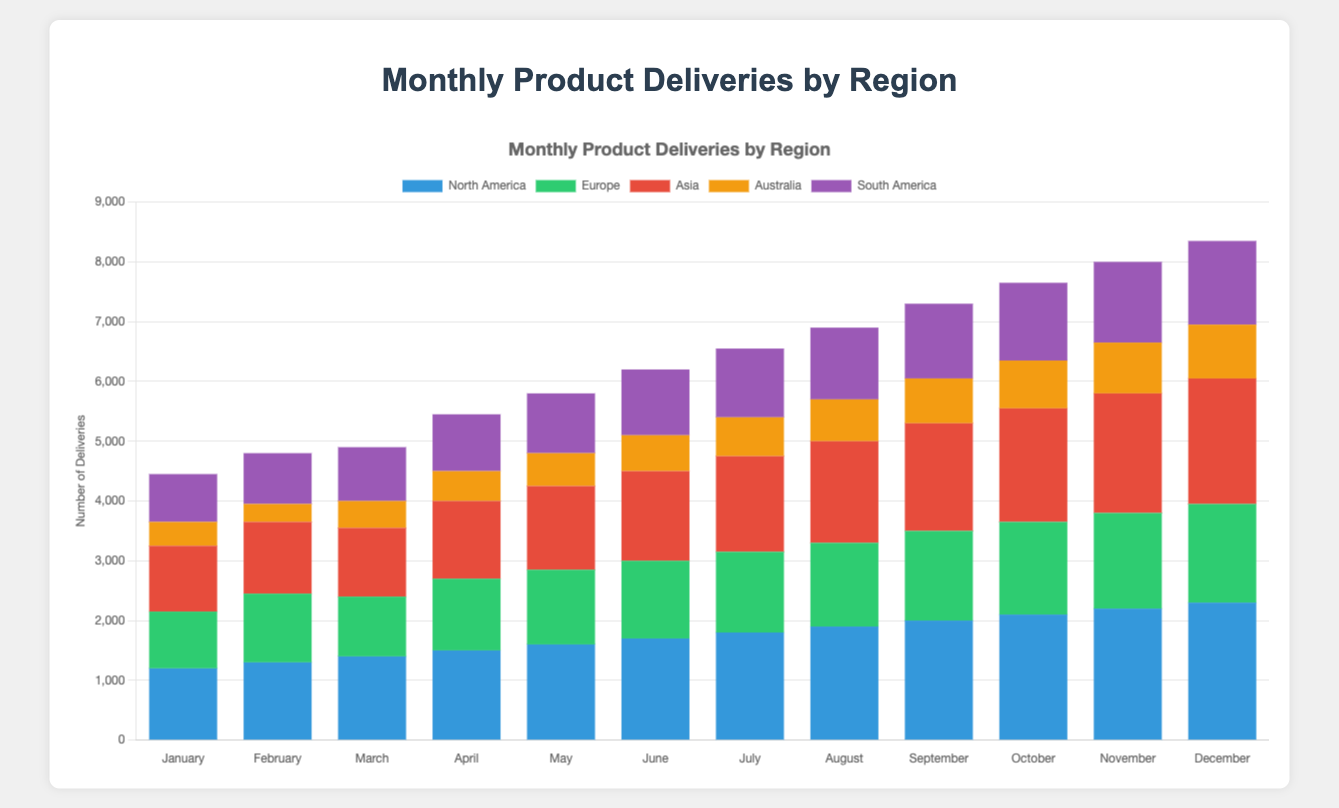Which month had the highest total deliveries? To find this, sum up the deliveries by region for each month and compare. December has the highest (2300 + 1650 + 2100 + 900 + 1400 = 8350)
Answer: December Which region showed the most consistent delivery numbers throughout the year? Consistent delivery numbers mean less variation month-to-month. North America’s deliveries show a steady increase each month rather than sharp increases or decreases, indicating the most consistency.
Answer: North America What is the difference in total deliveries between the month with the highest deliveries and the month with the lowest deliveries? Calculate the total deliveries for each month, identify the highest and lowest, then compute the difference. December’s highest deliveries (8350) and February’s lowest deliveries (4800). The difference is 8350 - 4800 = 3550.
Answer: 3550 Comparing deliveries in June and September, which region increased the most, and by how much? For each region, subtract June deliveries from September deliveries:
- North America: 2000 - 1700 = 300
- Europe: 1500 - 1300 = 200
- Asia: 1800 - 1500 = 300
- Australia: 750 - 600 = 150
- South America: 1250 - 1100 = 150
North America and Asia both increased by the most, which is 300.
Answer: North America and Asia, 300 Which month had equal or nearly equal deliveries in North America and Europe? Compare deliveries in North America and Europe month-by-month. In October, North America had 2100 and Europe had 1550. Although these numbers are close, no month had truly equal or nearly equal deliveries.
Answer: None What is the total number of deliveries to South America for the first quarter (January to March)? Add South American deliveries for January, February, and March: 800 + 850 + 900 = 2550.
Answer: 2550 What was the average monthly delivery to Asia over the year? Sum up the deliveries to Asia for each month and divide by 12: (1100+1200+1150+1300+1400+1500+1600+1700+1800+1900+2000+2100)/12 = 16650/12 ≈ 1387.5.
Answer: 1387.5 Which region had the steepest growth in deliveries from the beginning of the year to the end? Calculate the increase for each region from January to December:
- North America: 2300 - 1200 = 1100
- Europe: 1650 - 950 = 700
- Asia: 2100 - 1100 = 1000
- Australia: 900 - 400 = 500
- South America: 1400 - 800 = 600
North America had the steepest growth of 1100.
Answer: North America In which month did deliveries to Australia exceed 500? Examine the values month-by-month. From May onward, deliveries to Australia consistently exceeded 500 (550 in May, 600 in June, etc.).
Answer: May onward How did the deliveries to Europe trend from January to December? Observe the delivery numbers for Europe from month to month. The deliveries showed a generally increasing trend from 950 in January to 1650 in December.
Answer: Increasing 